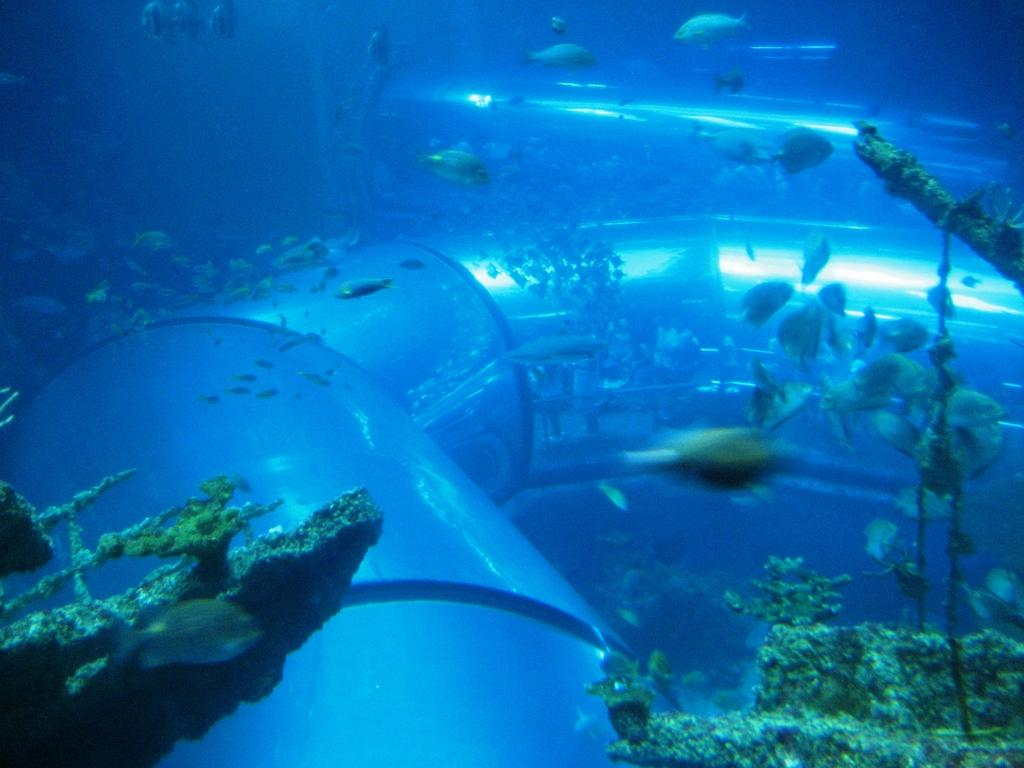What type of animals can be seen in the image? There are fishes in the image. What structure is present in the image? There is a pipeline in the image. What type of vegetation is visible in the image? There are sea plants in the image. What is the predominant color of the image? The image has a blue color. What type of coil is present in the image? There is no coil present in the image; it features fishes, a pipeline, sea plants, and has a blue color. What angle is the plate positioned at in the image? There is no plate present in the image. 